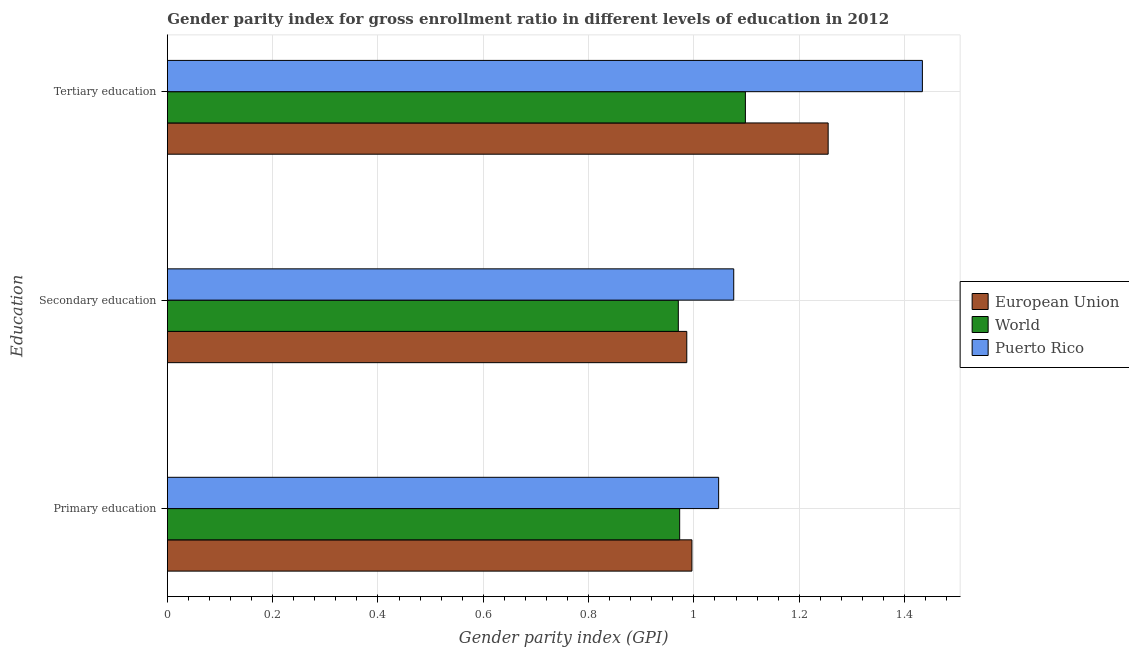How many different coloured bars are there?
Offer a very short reply. 3. Are the number of bars per tick equal to the number of legend labels?
Your response must be concise. Yes. How many bars are there on the 3rd tick from the top?
Make the answer very short. 3. How many bars are there on the 2nd tick from the bottom?
Offer a very short reply. 3. What is the label of the 2nd group of bars from the top?
Keep it short and to the point. Secondary education. What is the gender parity index in primary education in Puerto Rico?
Your response must be concise. 1.05. Across all countries, what is the maximum gender parity index in primary education?
Offer a terse response. 1.05. Across all countries, what is the minimum gender parity index in primary education?
Provide a short and direct response. 0.97. In which country was the gender parity index in primary education maximum?
Offer a very short reply. Puerto Rico. In which country was the gender parity index in secondary education minimum?
Provide a succinct answer. World. What is the total gender parity index in tertiary education in the graph?
Provide a short and direct response. 3.79. What is the difference between the gender parity index in secondary education in European Union and that in Puerto Rico?
Ensure brevity in your answer.  -0.09. What is the difference between the gender parity index in primary education in European Union and the gender parity index in secondary education in Puerto Rico?
Your answer should be compact. -0.08. What is the average gender parity index in primary education per country?
Make the answer very short. 1.01. What is the difference between the gender parity index in tertiary education and gender parity index in secondary education in European Union?
Make the answer very short. 0.27. What is the ratio of the gender parity index in secondary education in European Union to that in Puerto Rico?
Offer a very short reply. 0.92. Is the gender parity index in secondary education in World less than that in European Union?
Offer a very short reply. Yes. What is the difference between the highest and the second highest gender parity index in secondary education?
Make the answer very short. 0.09. What is the difference between the highest and the lowest gender parity index in secondary education?
Offer a terse response. 0.11. Is the sum of the gender parity index in secondary education in Puerto Rico and European Union greater than the maximum gender parity index in primary education across all countries?
Make the answer very short. Yes. What does the 3rd bar from the bottom in Secondary education represents?
Your answer should be very brief. Puerto Rico. Is it the case that in every country, the sum of the gender parity index in primary education and gender parity index in secondary education is greater than the gender parity index in tertiary education?
Offer a very short reply. Yes. Are all the bars in the graph horizontal?
Your answer should be compact. Yes. How many countries are there in the graph?
Provide a succinct answer. 3. What is the difference between two consecutive major ticks on the X-axis?
Your response must be concise. 0.2. Does the graph contain grids?
Your answer should be very brief. Yes. Where does the legend appear in the graph?
Provide a short and direct response. Center right. What is the title of the graph?
Your answer should be compact. Gender parity index for gross enrollment ratio in different levels of education in 2012. Does "United States" appear as one of the legend labels in the graph?
Give a very brief answer. No. What is the label or title of the X-axis?
Your response must be concise. Gender parity index (GPI). What is the label or title of the Y-axis?
Ensure brevity in your answer.  Education. What is the Gender parity index (GPI) in European Union in Primary education?
Offer a very short reply. 1. What is the Gender parity index (GPI) in World in Primary education?
Provide a short and direct response. 0.97. What is the Gender parity index (GPI) in Puerto Rico in Primary education?
Provide a short and direct response. 1.05. What is the Gender parity index (GPI) of European Union in Secondary education?
Make the answer very short. 0.99. What is the Gender parity index (GPI) in World in Secondary education?
Your answer should be compact. 0.97. What is the Gender parity index (GPI) of Puerto Rico in Secondary education?
Your answer should be very brief. 1.08. What is the Gender parity index (GPI) in European Union in Tertiary education?
Provide a short and direct response. 1.26. What is the Gender parity index (GPI) in World in Tertiary education?
Ensure brevity in your answer.  1.1. What is the Gender parity index (GPI) in Puerto Rico in Tertiary education?
Provide a succinct answer. 1.43. Across all Education, what is the maximum Gender parity index (GPI) of European Union?
Your answer should be very brief. 1.26. Across all Education, what is the maximum Gender parity index (GPI) in World?
Your response must be concise. 1.1. Across all Education, what is the maximum Gender parity index (GPI) in Puerto Rico?
Ensure brevity in your answer.  1.43. Across all Education, what is the minimum Gender parity index (GPI) of European Union?
Offer a terse response. 0.99. Across all Education, what is the minimum Gender parity index (GPI) in World?
Give a very brief answer. 0.97. Across all Education, what is the minimum Gender parity index (GPI) of Puerto Rico?
Make the answer very short. 1.05. What is the total Gender parity index (GPI) of European Union in the graph?
Give a very brief answer. 3.24. What is the total Gender parity index (GPI) in World in the graph?
Make the answer very short. 3.04. What is the total Gender parity index (GPI) in Puerto Rico in the graph?
Make the answer very short. 3.56. What is the difference between the Gender parity index (GPI) in European Union in Primary education and that in Secondary education?
Provide a succinct answer. 0.01. What is the difference between the Gender parity index (GPI) of World in Primary education and that in Secondary education?
Your answer should be compact. 0. What is the difference between the Gender parity index (GPI) in Puerto Rico in Primary education and that in Secondary education?
Ensure brevity in your answer.  -0.03. What is the difference between the Gender parity index (GPI) in European Union in Primary education and that in Tertiary education?
Your response must be concise. -0.26. What is the difference between the Gender parity index (GPI) in World in Primary education and that in Tertiary education?
Offer a very short reply. -0.12. What is the difference between the Gender parity index (GPI) of Puerto Rico in Primary education and that in Tertiary education?
Keep it short and to the point. -0.39. What is the difference between the Gender parity index (GPI) of European Union in Secondary education and that in Tertiary education?
Provide a succinct answer. -0.27. What is the difference between the Gender parity index (GPI) in World in Secondary education and that in Tertiary education?
Provide a short and direct response. -0.13. What is the difference between the Gender parity index (GPI) of Puerto Rico in Secondary education and that in Tertiary education?
Ensure brevity in your answer.  -0.36. What is the difference between the Gender parity index (GPI) of European Union in Primary education and the Gender parity index (GPI) of World in Secondary education?
Provide a short and direct response. 0.03. What is the difference between the Gender parity index (GPI) of European Union in Primary education and the Gender parity index (GPI) of Puerto Rico in Secondary education?
Offer a very short reply. -0.08. What is the difference between the Gender parity index (GPI) of World in Primary education and the Gender parity index (GPI) of Puerto Rico in Secondary education?
Offer a very short reply. -0.1. What is the difference between the Gender parity index (GPI) in European Union in Primary education and the Gender parity index (GPI) in World in Tertiary education?
Give a very brief answer. -0.1. What is the difference between the Gender parity index (GPI) in European Union in Primary education and the Gender parity index (GPI) in Puerto Rico in Tertiary education?
Keep it short and to the point. -0.44. What is the difference between the Gender parity index (GPI) in World in Primary education and the Gender parity index (GPI) in Puerto Rico in Tertiary education?
Offer a very short reply. -0.46. What is the difference between the Gender parity index (GPI) of European Union in Secondary education and the Gender parity index (GPI) of World in Tertiary education?
Give a very brief answer. -0.11. What is the difference between the Gender parity index (GPI) of European Union in Secondary education and the Gender parity index (GPI) of Puerto Rico in Tertiary education?
Offer a terse response. -0.45. What is the difference between the Gender parity index (GPI) in World in Secondary education and the Gender parity index (GPI) in Puerto Rico in Tertiary education?
Your answer should be very brief. -0.46. What is the average Gender parity index (GPI) of European Union per Education?
Offer a terse response. 1.08. What is the average Gender parity index (GPI) in World per Education?
Your answer should be very brief. 1.01. What is the average Gender parity index (GPI) of Puerto Rico per Education?
Ensure brevity in your answer.  1.19. What is the difference between the Gender parity index (GPI) in European Union and Gender parity index (GPI) in World in Primary education?
Provide a short and direct response. 0.02. What is the difference between the Gender parity index (GPI) in European Union and Gender parity index (GPI) in Puerto Rico in Primary education?
Offer a very short reply. -0.05. What is the difference between the Gender parity index (GPI) of World and Gender parity index (GPI) of Puerto Rico in Primary education?
Your answer should be compact. -0.07. What is the difference between the Gender parity index (GPI) in European Union and Gender parity index (GPI) in World in Secondary education?
Your answer should be compact. 0.02. What is the difference between the Gender parity index (GPI) in European Union and Gender parity index (GPI) in Puerto Rico in Secondary education?
Offer a terse response. -0.09. What is the difference between the Gender parity index (GPI) in World and Gender parity index (GPI) in Puerto Rico in Secondary education?
Ensure brevity in your answer.  -0.11. What is the difference between the Gender parity index (GPI) of European Union and Gender parity index (GPI) of World in Tertiary education?
Offer a very short reply. 0.16. What is the difference between the Gender parity index (GPI) of European Union and Gender parity index (GPI) of Puerto Rico in Tertiary education?
Your response must be concise. -0.18. What is the difference between the Gender parity index (GPI) of World and Gender parity index (GPI) of Puerto Rico in Tertiary education?
Offer a very short reply. -0.34. What is the ratio of the Gender parity index (GPI) of European Union in Primary education to that in Secondary education?
Keep it short and to the point. 1.01. What is the ratio of the Gender parity index (GPI) in Puerto Rico in Primary education to that in Secondary education?
Offer a terse response. 0.97. What is the ratio of the Gender parity index (GPI) of European Union in Primary education to that in Tertiary education?
Offer a terse response. 0.79. What is the ratio of the Gender parity index (GPI) of World in Primary education to that in Tertiary education?
Ensure brevity in your answer.  0.89. What is the ratio of the Gender parity index (GPI) of Puerto Rico in Primary education to that in Tertiary education?
Keep it short and to the point. 0.73. What is the ratio of the Gender parity index (GPI) in European Union in Secondary education to that in Tertiary education?
Provide a succinct answer. 0.79. What is the ratio of the Gender parity index (GPI) of World in Secondary education to that in Tertiary education?
Provide a short and direct response. 0.88. What is the ratio of the Gender parity index (GPI) in Puerto Rico in Secondary education to that in Tertiary education?
Provide a short and direct response. 0.75. What is the difference between the highest and the second highest Gender parity index (GPI) in European Union?
Offer a very short reply. 0.26. What is the difference between the highest and the second highest Gender parity index (GPI) of World?
Your response must be concise. 0.12. What is the difference between the highest and the second highest Gender parity index (GPI) of Puerto Rico?
Make the answer very short. 0.36. What is the difference between the highest and the lowest Gender parity index (GPI) in European Union?
Your answer should be very brief. 0.27. What is the difference between the highest and the lowest Gender parity index (GPI) in World?
Keep it short and to the point. 0.13. What is the difference between the highest and the lowest Gender parity index (GPI) of Puerto Rico?
Offer a terse response. 0.39. 